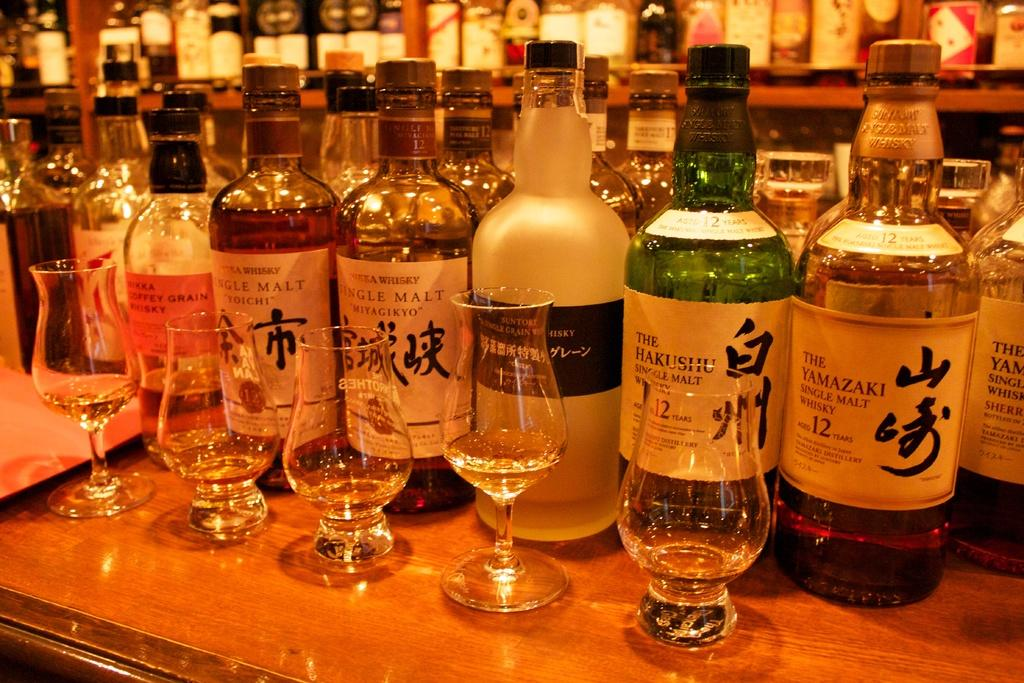What can be found on the table in the image? There are wine bottles and glasses on the table. Where are the wine bottles located in the image? The wine bottles are on the table and also on a shelf in the background. What is the purpose of the glasses on the table? The glasses on the table are likely for drinking the wine. What shape is the knee of the person sitting at the table in the image? There is no person sitting at the table in the image, so we cannot determine the shape of their knee. 